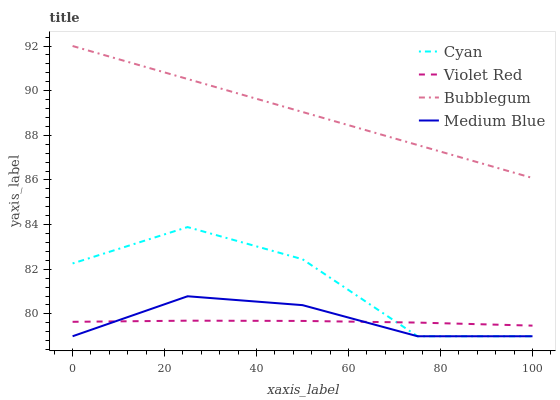Does Violet Red have the minimum area under the curve?
Answer yes or no. Yes. Does Bubblegum have the maximum area under the curve?
Answer yes or no. Yes. Does Medium Blue have the minimum area under the curve?
Answer yes or no. No. Does Medium Blue have the maximum area under the curve?
Answer yes or no. No. Is Bubblegum the smoothest?
Answer yes or no. Yes. Is Cyan the roughest?
Answer yes or no. Yes. Is Violet Red the smoothest?
Answer yes or no. No. Is Violet Red the roughest?
Answer yes or no. No. Does Cyan have the lowest value?
Answer yes or no. Yes. Does Violet Red have the lowest value?
Answer yes or no. No. Does Bubblegum have the highest value?
Answer yes or no. Yes. Does Medium Blue have the highest value?
Answer yes or no. No. Is Medium Blue less than Bubblegum?
Answer yes or no. Yes. Is Bubblegum greater than Violet Red?
Answer yes or no. Yes. Does Medium Blue intersect Violet Red?
Answer yes or no. Yes. Is Medium Blue less than Violet Red?
Answer yes or no. No. Is Medium Blue greater than Violet Red?
Answer yes or no. No. Does Medium Blue intersect Bubblegum?
Answer yes or no. No. 